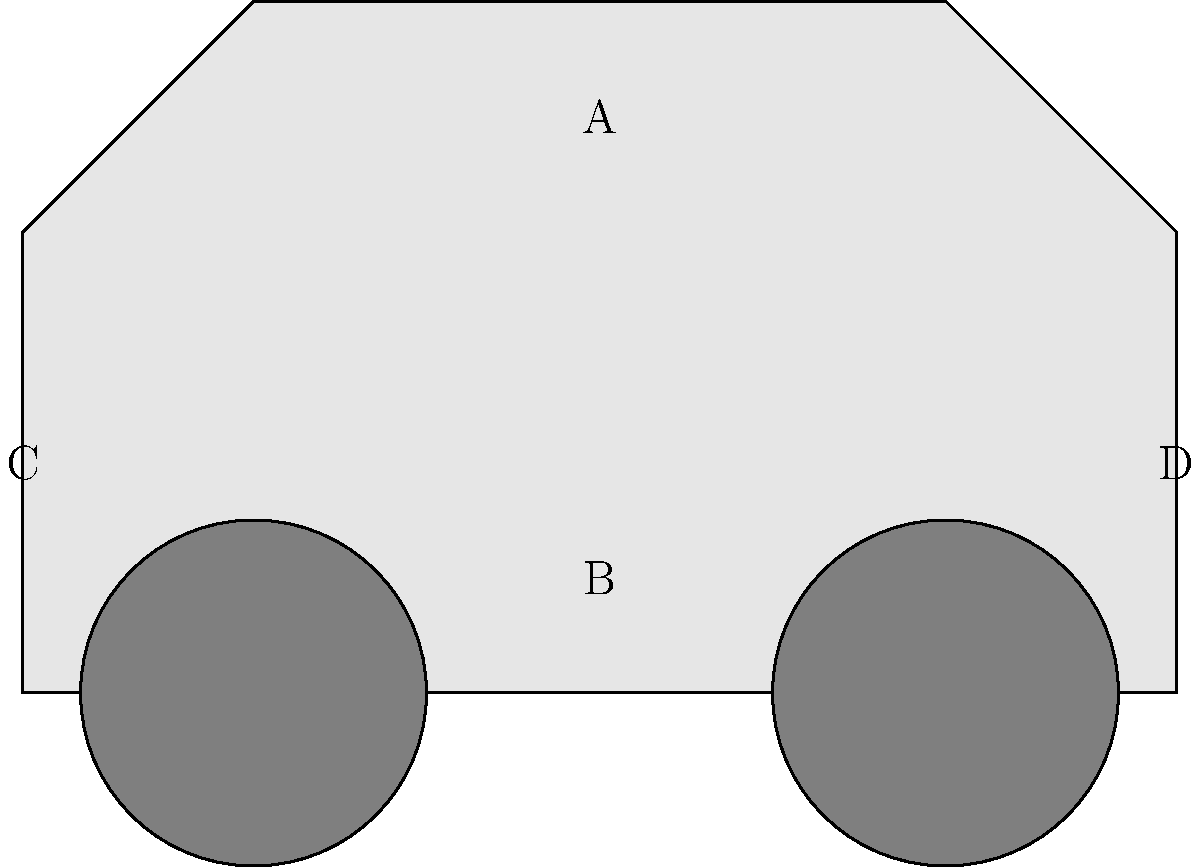Match the following car parts to their corresponding locations on the generic car diagram:

1. Engine
2. Transmission
3. Front bumper
4. Rear bumper To correctly match the car parts with their locations, let's consider each part's typical position in a standard car layout:

1. Engine: The engine is usually located in the front of the car, under the hood. In our diagram, this corresponds to area A, which is the front upper portion of the car.

2. Transmission: The transmission is typically positioned behind the engine and extends towards the center of the car. In our diagram, this would be represented by area B, which is the lower central portion of the vehicle.

3. Front bumper: The front bumper is always located at the very front of the car, serving as the first line of protection in case of a frontal collision. In our diagram, this is represented by area C, at the front-most part of the car.

4. Rear bumper: Similarly, the rear bumper is always located at the very back of the car, protecting the vehicle in case of a rear-end collision. In our diagram, this corresponds to area D, at the rear-most part of the car.

Therefore, the correct matching is:
1. Engine - A
2. Transmission - B
3. Front bumper - C
4. Rear bumper - D
Answer: 1-A, 2-B, 3-C, 4-D 